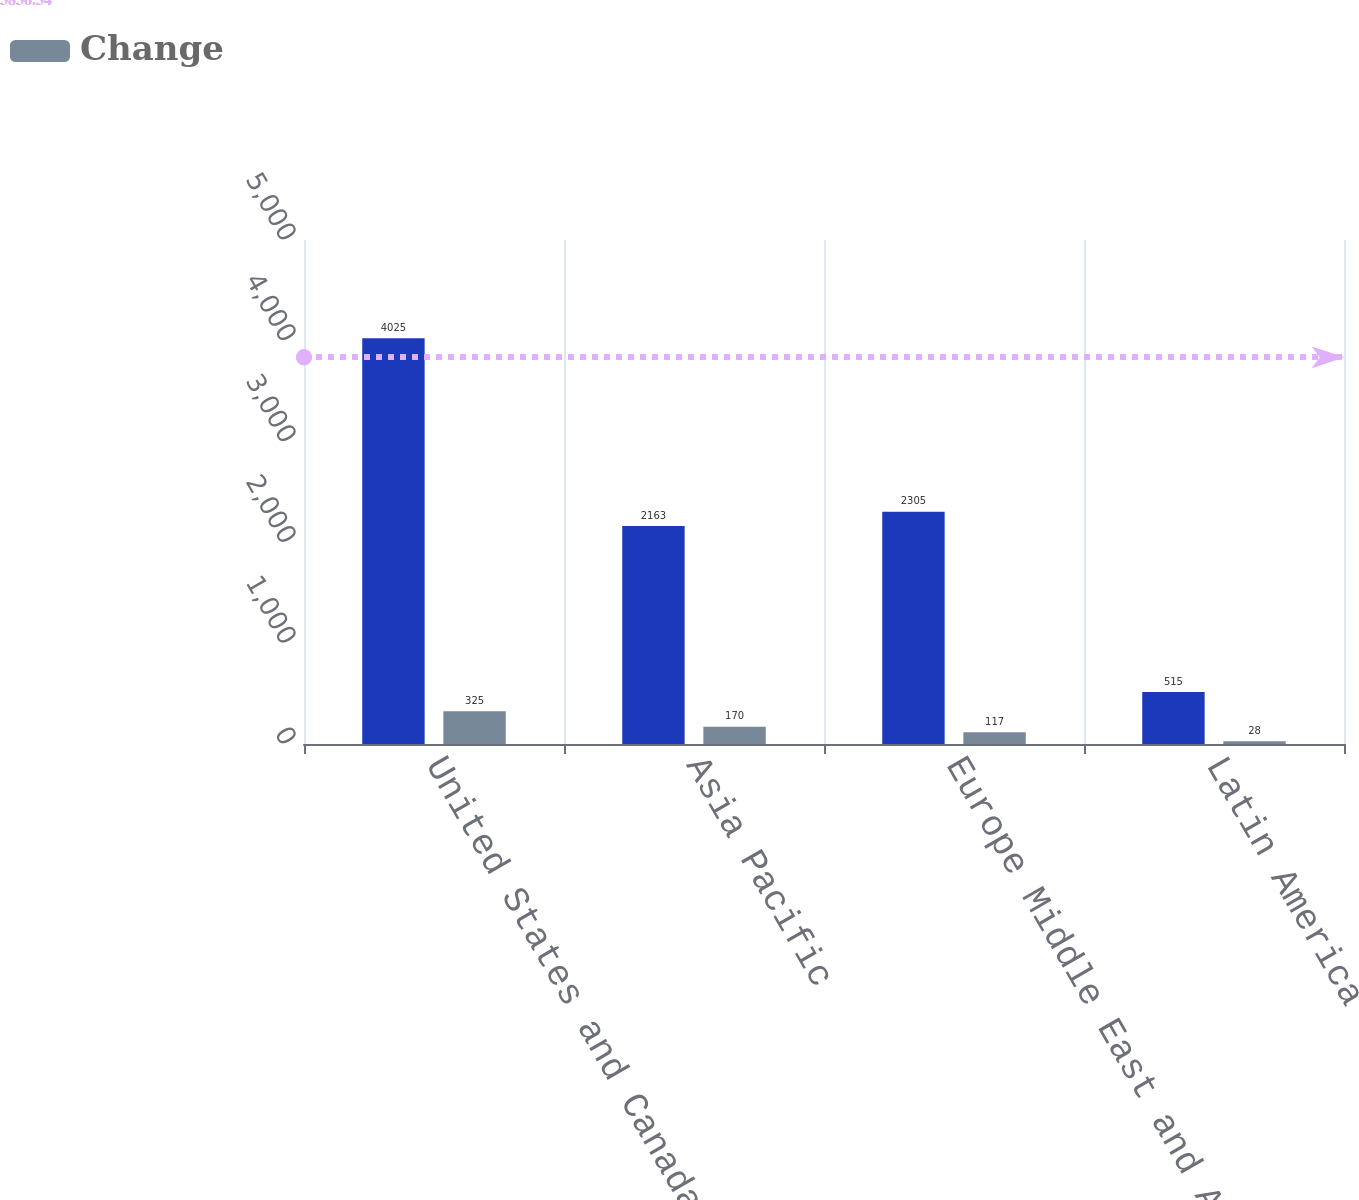Convert chart to OTSL. <chart><loc_0><loc_0><loc_500><loc_500><stacked_bar_chart><ecel><fcel>United States and Canada<fcel>Asia Pacific<fcel>Europe Middle East and Africa<fcel>Latin America<nl><fcel>nan<fcel>4025<fcel>2163<fcel>2305<fcel>515<nl><fcel>Change<fcel>325<fcel>170<fcel>117<fcel>28<nl></chart> 